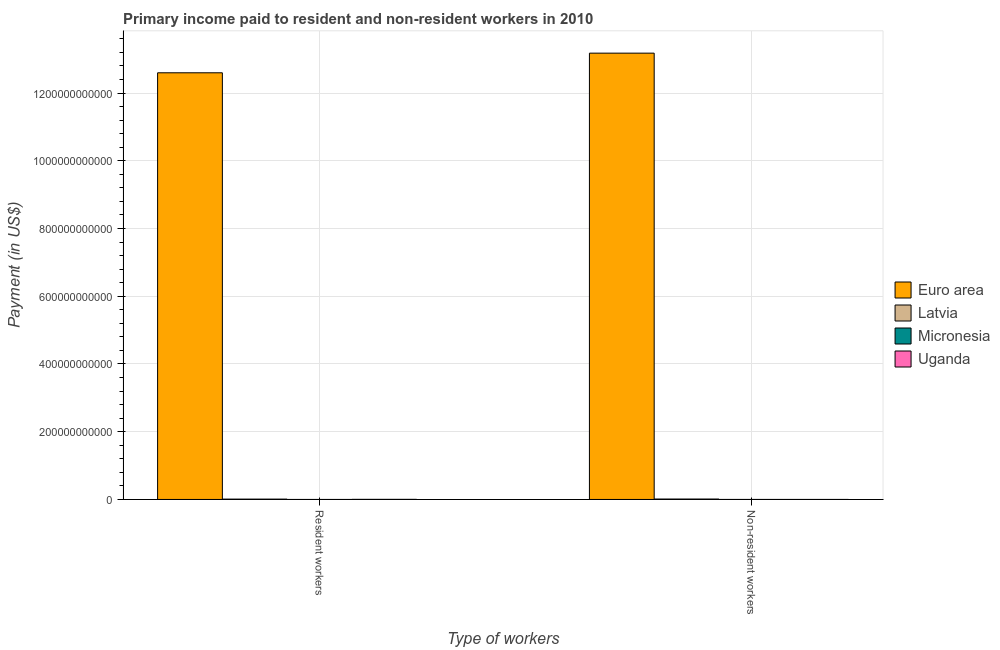How many groups of bars are there?
Ensure brevity in your answer.  2. Are the number of bars on each tick of the X-axis equal?
Offer a very short reply. Yes. How many bars are there on the 1st tick from the right?
Offer a terse response. 4. What is the label of the 2nd group of bars from the left?
Ensure brevity in your answer.  Non-resident workers. What is the payment made to resident workers in Euro area?
Offer a very short reply. 1.26e+12. Across all countries, what is the maximum payment made to non-resident workers?
Provide a succinct answer. 1.32e+12. Across all countries, what is the minimum payment made to non-resident workers?
Give a very brief answer. 2.32e+07. In which country was the payment made to resident workers maximum?
Offer a very short reply. Euro area. In which country was the payment made to resident workers minimum?
Keep it short and to the point. Micronesia. What is the total payment made to non-resident workers in the graph?
Make the answer very short. 1.32e+12. What is the difference between the payment made to resident workers in Uganda and that in Euro area?
Ensure brevity in your answer.  -1.26e+12. What is the difference between the payment made to resident workers in Euro area and the payment made to non-resident workers in Latvia?
Ensure brevity in your answer.  1.26e+12. What is the average payment made to resident workers per country?
Offer a terse response. 3.15e+11. What is the difference between the payment made to non-resident workers and payment made to resident workers in Latvia?
Give a very brief answer. 2.56e+08. What is the ratio of the payment made to resident workers in Euro area to that in Latvia?
Offer a terse response. 1259.18. Is the payment made to non-resident workers in Micronesia less than that in Latvia?
Offer a very short reply. Yes. In how many countries, is the payment made to resident workers greater than the average payment made to resident workers taken over all countries?
Offer a very short reply. 1. What does the 2nd bar from the left in Resident workers represents?
Offer a very short reply. Latvia. What does the 4th bar from the right in Non-resident workers represents?
Ensure brevity in your answer.  Euro area. Are all the bars in the graph horizontal?
Provide a short and direct response. No. How many countries are there in the graph?
Offer a terse response. 4. What is the difference between two consecutive major ticks on the Y-axis?
Your answer should be compact. 2.00e+11. Does the graph contain grids?
Your answer should be very brief. Yes. How many legend labels are there?
Keep it short and to the point. 4. What is the title of the graph?
Offer a terse response. Primary income paid to resident and non-resident workers in 2010. Does "Albania" appear as one of the legend labels in the graph?
Provide a short and direct response. No. What is the label or title of the X-axis?
Your answer should be compact. Type of workers. What is the label or title of the Y-axis?
Your answer should be very brief. Payment (in US$). What is the Payment (in US$) in Euro area in Resident workers?
Provide a short and direct response. 1.26e+12. What is the Payment (in US$) of Latvia in Resident workers?
Your answer should be compact. 1.00e+09. What is the Payment (in US$) in Micronesia in Resident workers?
Provide a short and direct response. 1.25e+07. What is the Payment (in US$) of Uganda in Resident workers?
Provide a short and direct response. 3.21e+08. What is the Payment (in US$) of Euro area in Non-resident workers?
Your answer should be very brief. 1.32e+12. What is the Payment (in US$) of Latvia in Non-resident workers?
Provide a succinct answer. 1.26e+09. What is the Payment (in US$) of Micronesia in Non-resident workers?
Give a very brief answer. 2.35e+07. What is the Payment (in US$) in Uganda in Non-resident workers?
Provide a short and direct response. 2.32e+07. Across all Type of workers, what is the maximum Payment (in US$) in Euro area?
Offer a terse response. 1.32e+12. Across all Type of workers, what is the maximum Payment (in US$) of Latvia?
Give a very brief answer. 1.26e+09. Across all Type of workers, what is the maximum Payment (in US$) of Micronesia?
Your response must be concise. 2.35e+07. Across all Type of workers, what is the maximum Payment (in US$) of Uganda?
Your answer should be compact. 3.21e+08. Across all Type of workers, what is the minimum Payment (in US$) of Euro area?
Offer a terse response. 1.26e+12. Across all Type of workers, what is the minimum Payment (in US$) in Latvia?
Offer a very short reply. 1.00e+09. Across all Type of workers, what is the minimum Payment (in US$) of Micronesia?
Offer a terse response. 1.25e+07. Across all Type of workers, what is the minimum Payment (in US$) in Uganda?
Your answer should be compact. 2.32e+07. What is the total Payment (in US$) of Euro area in the graph?
Your answer should be very brief. 2.58e+12. What is the total Payment (in US$) of Latvia in the graph?
Provide a short and direct response. 2.26e+09. What is the total Payment (in US$) in Micronesia in the graph?
Keep it short and to the point. 3.60e+07. What is the total Payment (in US$) of Uganda in the graph?
Provide a succinct answer. 3.45e+08. What is the difference between the Payment (in US$) in Euro area in Resident workers and that in Non-resident workers?
Offer a terse response. -5.80e+1. What is the difference between the Payment (in US$) in Latvia in Resident workers and that in Non-resident workers?
Ensure brevity in your answer.  -2.56e+08. What is the difference between the Payment (in US$) of Micronesia in Resident workers and that in Non-resident workers?
Ensure brevity in your answer.  -1.10e+07. What is the difference between the Payment (in US$) in Uganda in Resident workers and that in Non-resident workers?
Ensure brevity in your answer.  2.98e+08. What is the difference between the Payment (in US$) of Euro area in Resident workers and the Payment (in US$) of Latvia in Non-resident workers?
Make the answer very short. 1.26e+12. What is the difference between the Payment (in US$) in Euro area in Resident workers and the Payment (in US$) in Micronesia in Non-resident workers?
Make the answer very short. 1.26e+12. What is the difference between the Payment (in US$) of Euro area in Resident workers and the Payment (in US$) of Uganda in Non-resident workers?
Provide a succinct answer. 1.26e+12. What is the difference between the Payment (in US$) in Latvia in Resident workers and the Payment (in US$) in Micronesia in Non-resident workers?
Your response must be concise. 9.77e+08. What is the difference between the Payment (in US$) of Latvia in Resident workers and the Payment (in US$) of Uganda in Non-resident workers?
Your answer should be very brief. 9.77e+08. What is the difference between the Payment (in US$) in Micronesia in Resident workers and the Payment (in US$) in Uganda in Non-resident workers?
Your response must be concise. -1.07e+07. What is the average Payment (in US$) of Euro area per Type of workers?
Give a very brief answer. 1.29e+12. What is the average Payment (in US$) in Latvia per Type of workers?
Your answer should be very brief. 1.13e+09. What is the average Payment (in US$) in Micronesia per Type of workers?
Your answer should be compact. 1.80e+07. What is the average Payment (in US$) in Uganda per Type of workers?
Provide a succinct answer. 1.72e+08. What is the difference between the Payment (in US$) in Euro area and Payment (in US$) in Latvia in Resident workers?
Make the answer very short. 1.26e+12. What is the difference between the Payment (in US$) of Euro area and Payment (in US$) of Micronesia in Resident workers?
Make the answer very short. 1.26e+12. What is the difference between the Payment (in US$) of Euro area and Payment (in US$) of Uganda in Resident workers?
Give a very brief answer. 1.26e+12. What is the difference between the Payment (in US$) in Latvia and Payment (in US$) in Micronesia in Resident workers?
Provide a short and direct response. 9.88e+08. What is the difference between the Payment (in US$) in Latvia and Payment (in US$) in Uganda in Resident workers?
Offer a terse response. 6.79e+08. What is the difference between the Payment (in US$) of Micronesia and Payment (in US$) of Uganda in Resident workers?
Give a very brief answer. -3.09e+08. What is the difference between the Payment (in US$) in Euro area and Payment (in US$) in Latvia in Non-resident workers?
Ensure brevity in your answer.  1.32e+12. What is the difference between the Payment (in US$) of Euro area and Payment (in US$) of Micronesia in Non-resident workers?
Your answer should be very brief. 1.32e+12. What is the difference between the Payment (in US$) in Euro area and Payment (in US$) in Uganda in Non-resident workers?
Your response must be concise. 1.32e+12. What is the difference between the Payment (in US$) in Latvia and Payment (in US$) in Micronesia in Non-resident workers?
Give a very brief answer. 1.23e+09. What is the difference between the Payment (in US$) of Latvia and Payment (in US$) of Uganda in Non-resident workers?
Provide a succinct answer. 1.23e+09. What is the difference between the Payment (in US$) in Micronesia and Payment (in US$) in Uganda in Non-resident workers?
Your response must be concise. 2.83e+05. What is the ratio of the Payment (in US$) of Euro area in Resident workers to that in Non-resident workers?
Provide a short and direct response. 0.96. What is the ratio of the Payment (in US$) in Latvia in Resident workers to that in Non-resident workers?
Ensure brevity in your answer.  0.8. What is the ratio of the Payment (in US$) in Micronesia in Resident workers to that in Non-resident workers?
Make the answer very short. 0.53. What is the ratio of the Payment (in US$) in Uganda in Resident workers to that in Non-resident workers?
Ensure brevity in your answer.  13.85. What is the difference between the highest and the second highest Payment (in US$) of Euro area?
Give a very brief answer. 5.80e+1. What is the difference between the highest and the second highest Payment (in US$) of Latvia?
Your answer should be very brief. 2.56e+08. What is the difference between the highest and the second highest Payment (in US$) in Micronesia?
Your response must be concise. 1.10e+07. What is the difference between the highest and the second highest Payment (in US$) of Uganda?
Offer a very short reply. 2.98e+08. What is the difference between the highest and the lowest Payment (in US$) of Euro area?
Provide a short and direct response. 5.80e+1. What is the difference between the highest and the lowest Payment (in US$) of Latvia?
Offer a very short reply. 2.56e+08. What is the difference between the highest and the lowest Payment (in US$) in Micronesia?
Make the answer very short. 1.10e+07. What is the difference between the highest and the lowest Payment (in US$) of Uganda?
Offer a terse response. 2.98e+08. 